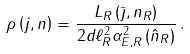<formula> <loc_0><loc_0><loc_500><loc_500>\rho \left ( j , n \right ) = \frac { L _ { R } \left ( \bar { \jmath } , n _ { R } \right ) } { 2 d \ell ^ { 2 } _ { R } \alpha ^ { 2 } _ { E , R } \left ( \hat { n } _ { R } \right ) } \, .</formula> 